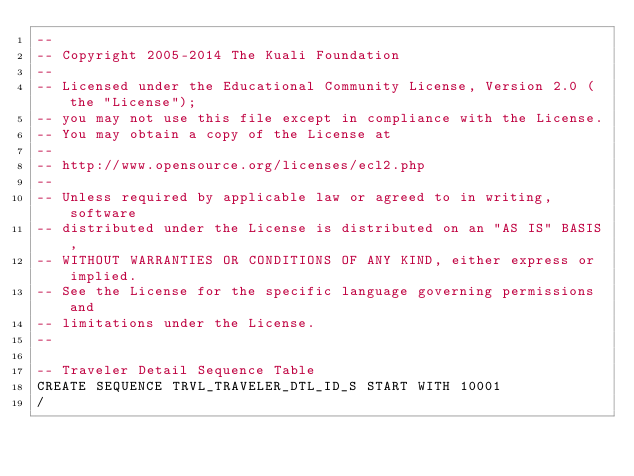<code> <loc_0><loc_0><loc_500><loc_500><_SQL_>--
-- Copyright 2005-2014 The Kuali Foundation
--
-- Licensed under the Educational Community License, Version 2.0 (the "License");
-- you may not use this file except in compliance with the License.
-- You may obtain a copy of the License at
--
-- http://www.opensource.org/licenses/ecl2.php
--
-- Unless required by applicable law or agreed to in writing, software
-- distributed under the License is distributed on an "AS IS" BASIS,
-- WITHOUT WARRANTIES OR CONDITIONS OF ANY KIND, either express or implied.
-- See the License for the specific language governing permissions and
-- limitations under the License.
--

-- Traveler Detail Sequence Table 
CREATE SEQUENCE TRVL_TRAVELER_DTL_ID_S START WITH 10001
/
</code> 